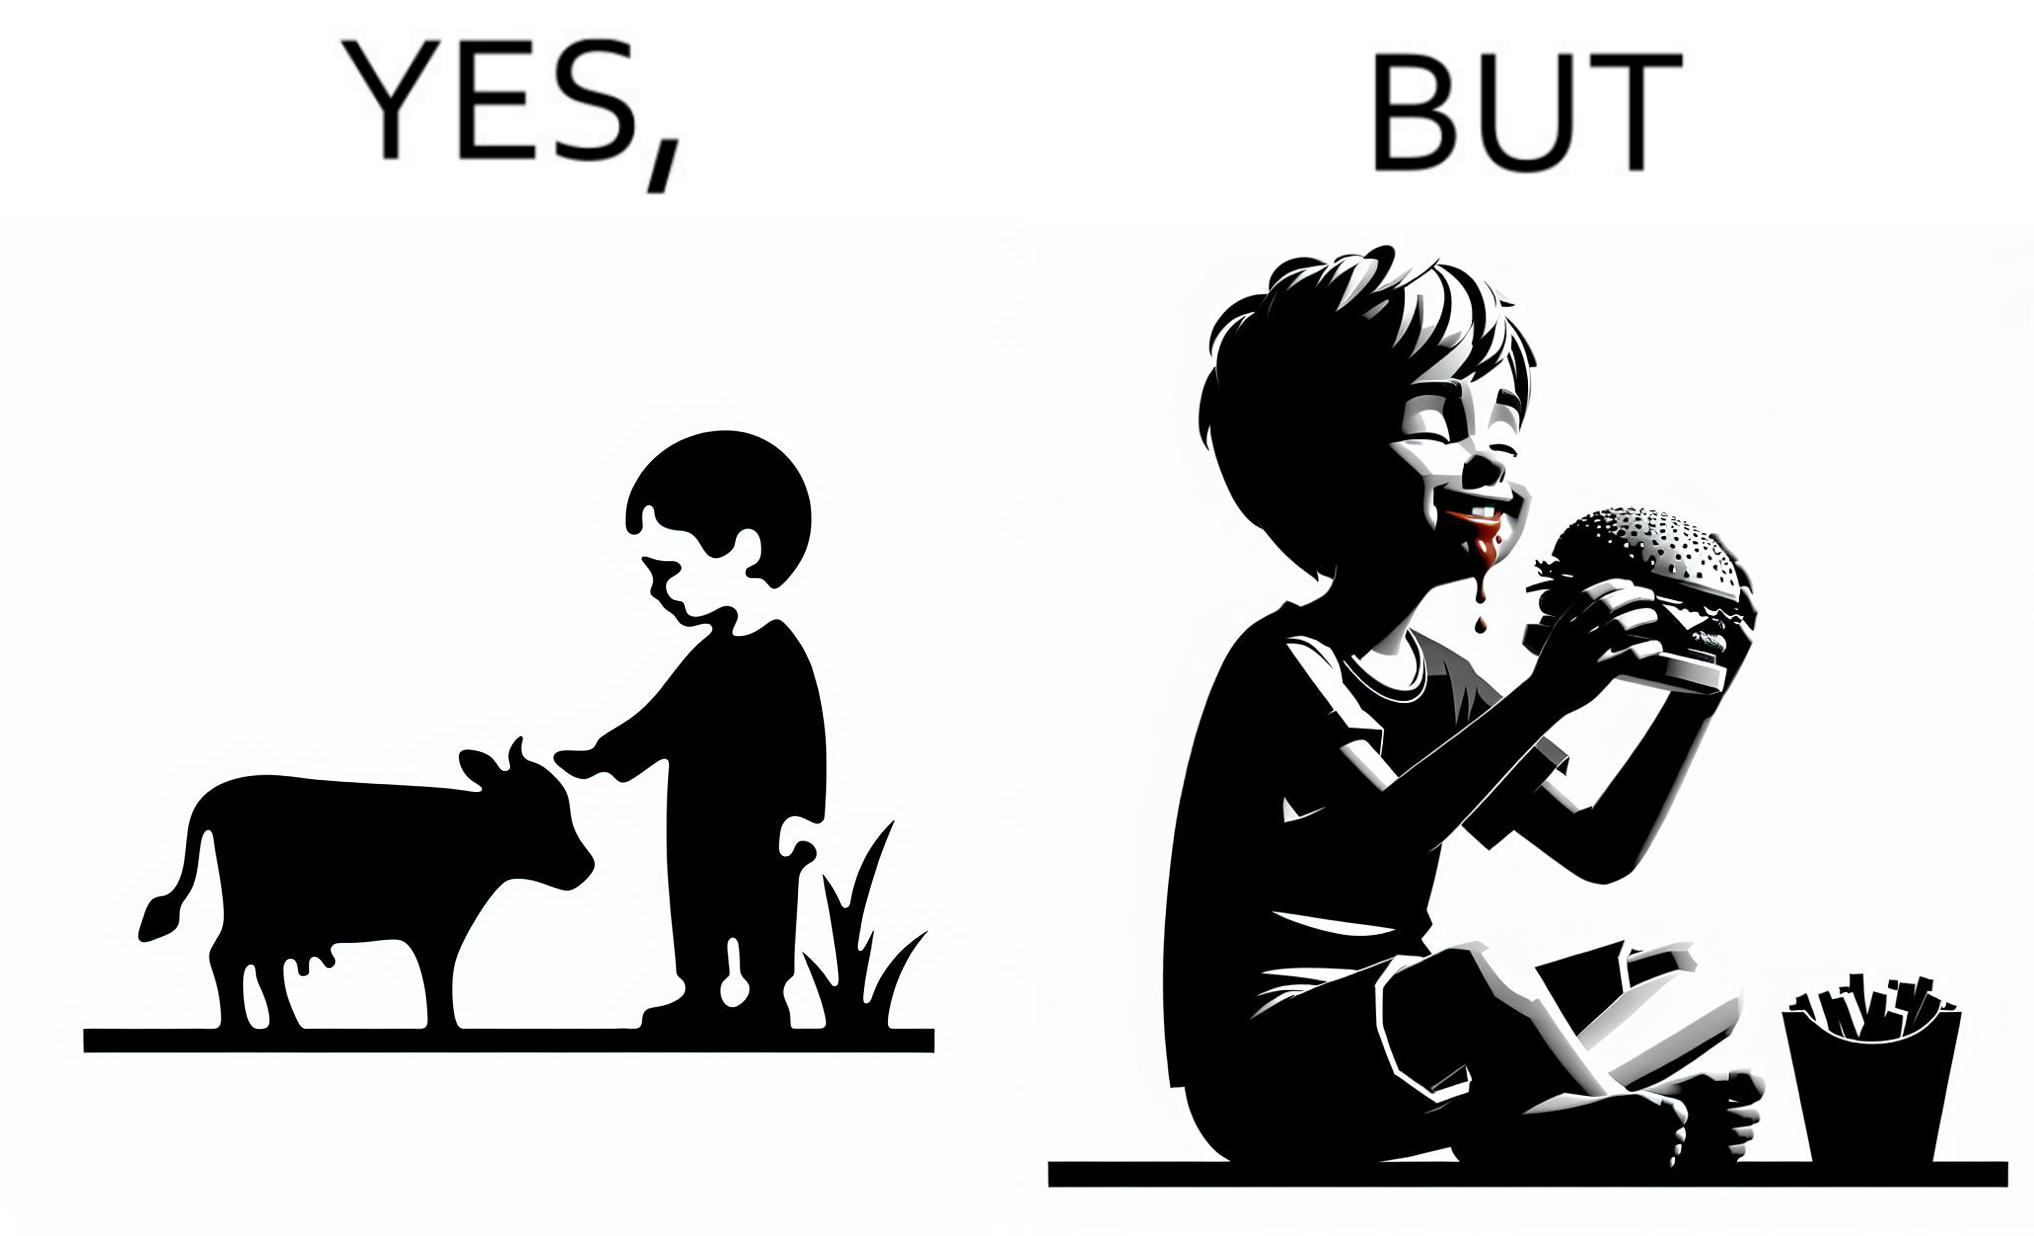Is there satirical content in this image? Yes, this image is satirical. 